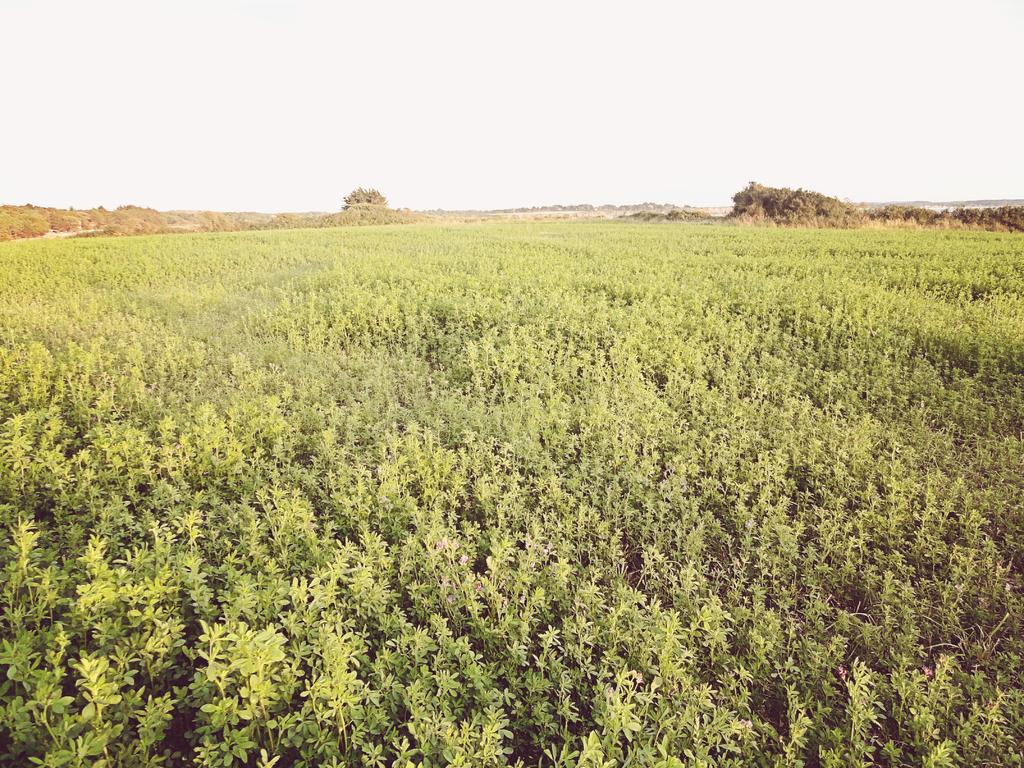What type of landscape is depicted in the image? The image contains farmland. What can be seen at the bottom of the image? There are plants and leaves at the bottom of the image. What is visible in the sky in the image? The sky and clouds are visible at the top of the image. What is located in the background of the image? There is a mountain and trees in the background of the image. Can you hear the baby laughing in the image? There is no baby or laughter present in the image; it features farmland, plants, leaves, sky, clouds, a mountain, and trees. 